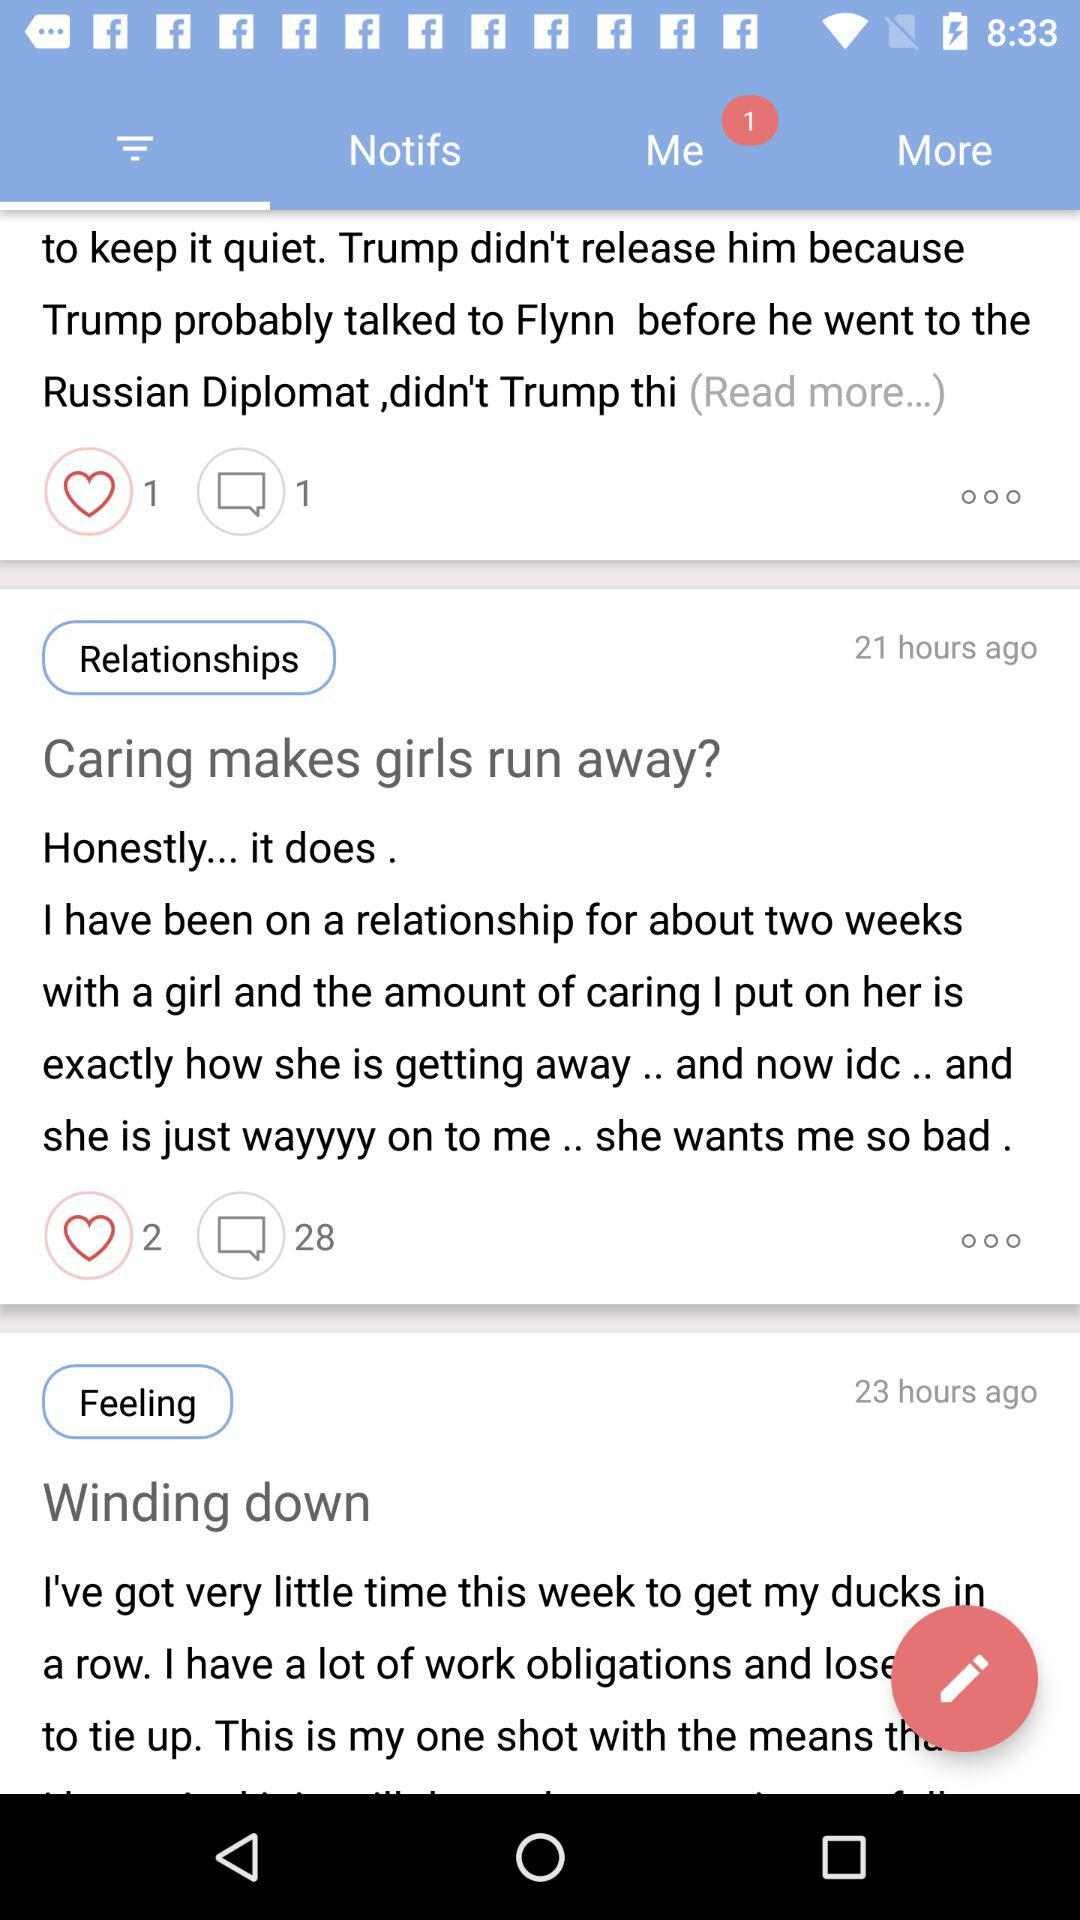How many likes are there of the article titled "Caring makes girls run away?"? There are 2 likes. 